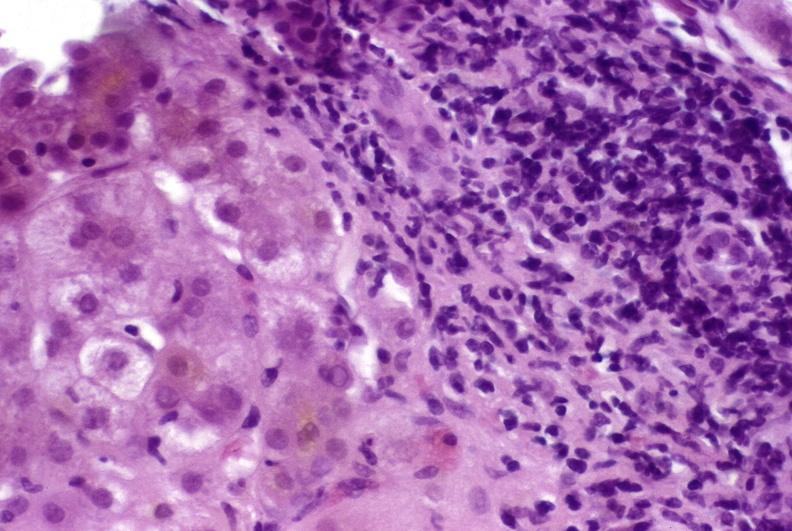s laceration present?
Answer the question using a single word or phrase. No 